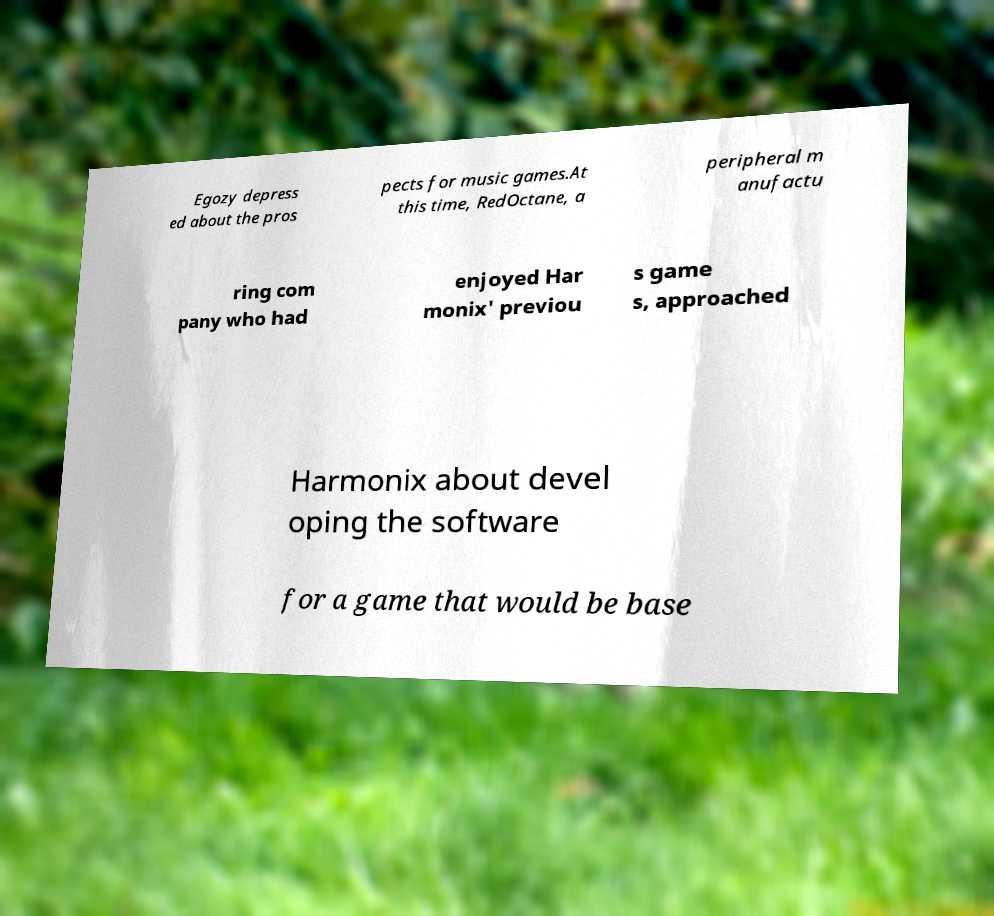For documentation purposes, I need the text within this image transcribed. Could you provide that? Egozy depress ed about the pros pects for music games.At this time, RedOctane, a peripheral m anufactu ring com pany who had enjoyed Har monix' previou s game s, approached Harmonix about devel oping the software for a game that would be base 